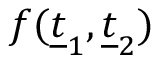<formula> <loc_0><loc_0><loc_500><loc_500>f ( \underline { t } _ { 1 } , \underline { t } _ { 2 } )</formula> 